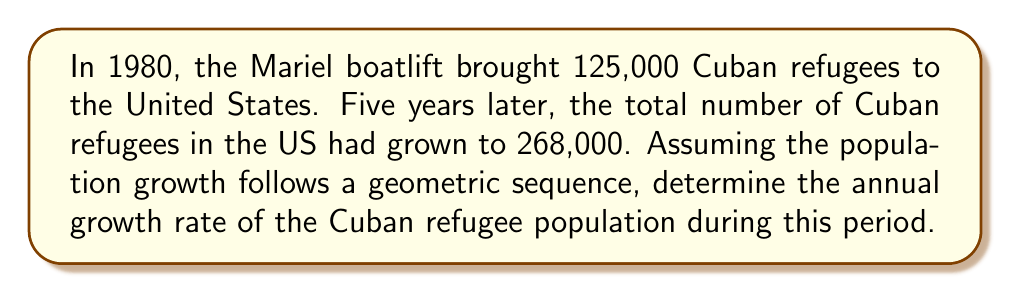Could you help me with this problem? Let's approach this step-by-step:

1) We have a geometric sequence with:
   Initial value (1980): $a = 125,000$
   Final value (1985): $268,000$
   Number of years: $n = 5$

2) In a geometric sequence, each term is $r$ times the previous term, where $r$ is the common ratio. In this case, $r$ represents the annual growth rate plus 1.

3) The formula for the nth term of a geometric sequence is:
   $a_n = a \cdot r^n$

4) Substituting our values:
   $268,000 = 125,000 \cdot r^5$

5) Divide both sides by 125,000:
   $\frac{268,000}{125,000} = r^5$

6) Simplify:
   $2.144 = r^5$

7) Take the 5th root of both sides:
   $r = \sqrt[5]{2.144}$

8) Calculate:
   $r \approx 1.1648$

9) The growth rate is $r - 1$:
   Growth rate $= 1.1648 - 1 = 0.1648$

10) Convert to percentage:
    $0.1648 \cdot 100\% = 16.48\%$

Therefore, the annual growth rate was approximately 16.48%.
Answer: 16.48% 